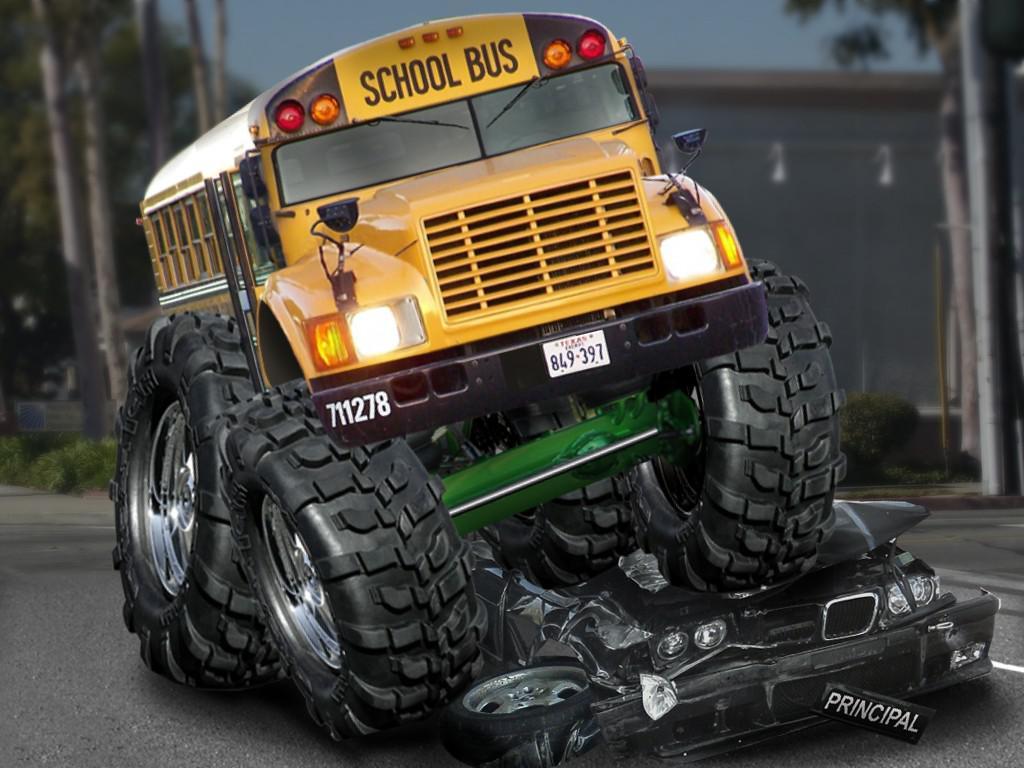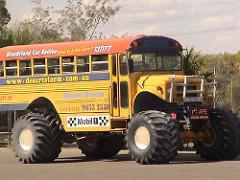The first image is the image on the left, the second image is the image on the right. Analyze the images presented: Is the assertion "One image shows a big-wheeled yellow school bus with its front tires on top of a squashed white car." valid? Answer yes or no. No. The first image is the image on the left, the second image is the image on the right. Analyze the images presented: Is the assertion "In the left image a monster bus is driving over another vehicle." valid? Answer yes or no. Yes. 